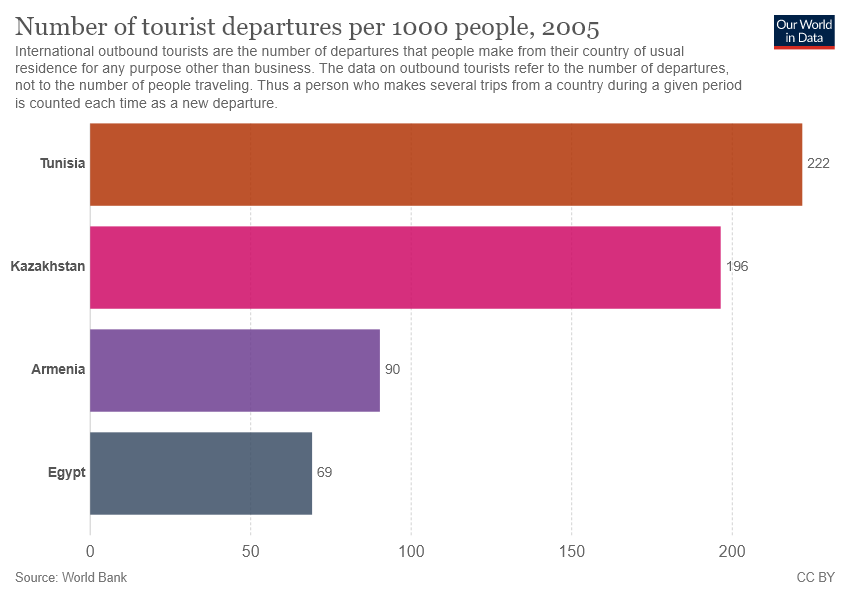Draw attention to some important aspects in this diagram. The value for Egypt is 69. In terms of total population, Tunisia is greater than Egypt by 3.217 times. 